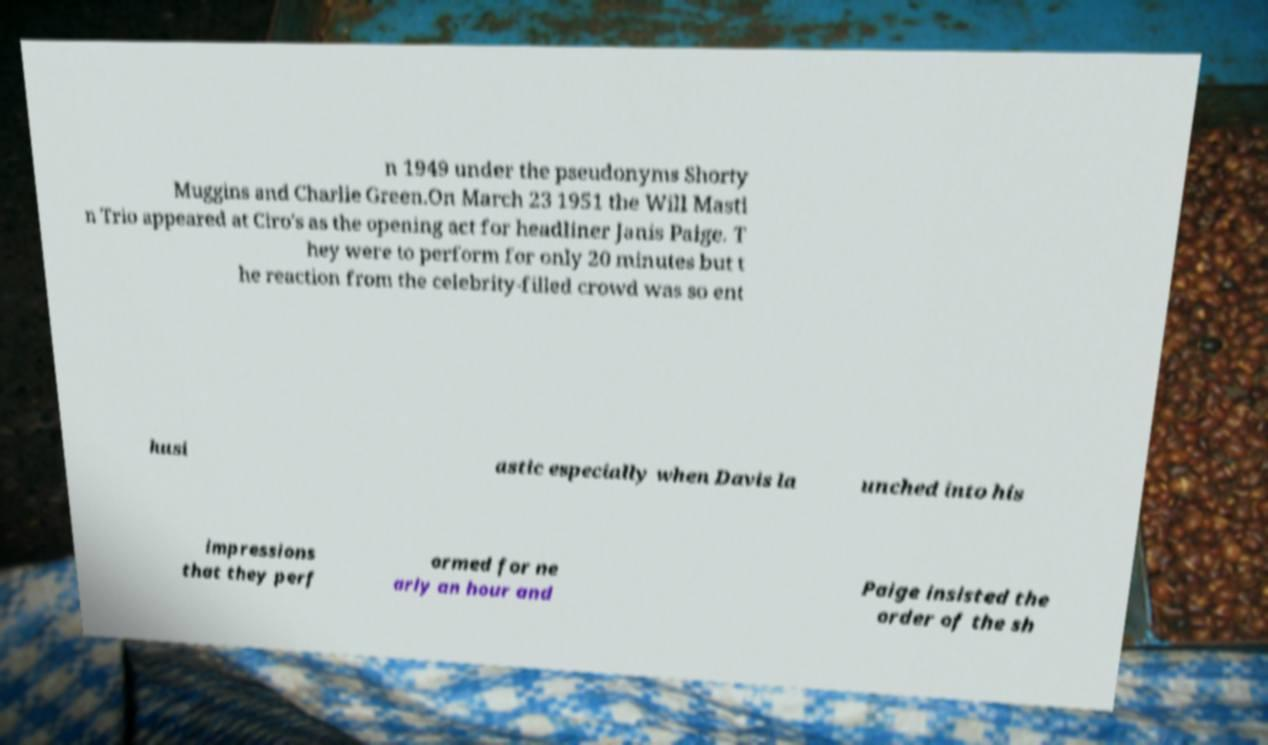Can you accurately transcribe the text from the provided image for me? n 1949 under the pseudonyms Shorty Muggins and Charlie Green.On March 23 1951 the Will Masti n Trio appeared at Ciro's as the opening act for headliner Janis Paige. T hey were to perform for only 20 minutes but t he reaction from the celebrity-filled crowd was so ent husi astic especially when Davis la unched into his impressions that they perf ormed for ne arly an hour and Paige insisted the order of the sh 